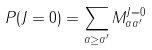<formula> <loc_0><loc_0><loc_500><loc_500>P ( J = 0 ) = \sum _ { \alpha \geq \alpha ^ { \prime } } M _ { \alpha \alpha ^ { \prime } } ^ { J = 0 }</formula> 